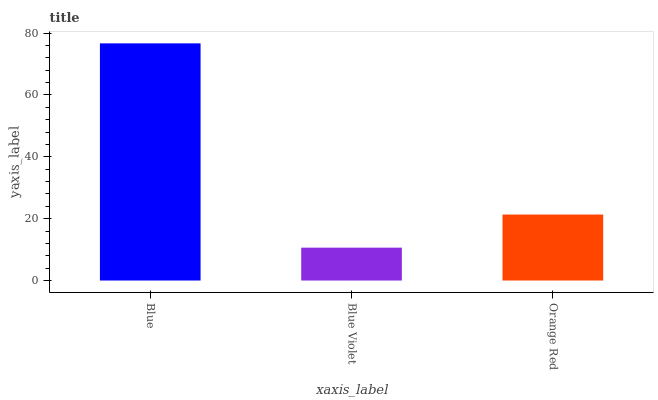Is Blue Violet the minimum?
Answer yes or no. Yes. Is Blue the maximum?
Answer yes or no. Yes. Is Orange Red the minimum?
Answer yes or no. No. Is Orange Red the maximum?
Answer yes or no. No. Is Orange Red greater than Blue Violet?
Answer yes or no. Yes. Is Blue Violet less than Orange Red?
Answer yes or no. Yes. Is Blue Violet greater than Orange Red?
Answer yes or no. No. Is Orange Red less than Blue Violet?
Answer yes or no. No. Is Orange Red the high median?
Answer yes or no. Yes. Is Orange Red the low median?
Answer yes or no. Yes. Is Blue Violet the high median?
Answer yes or no. No. Is Blue the low median?
Answer yes or no. No. 